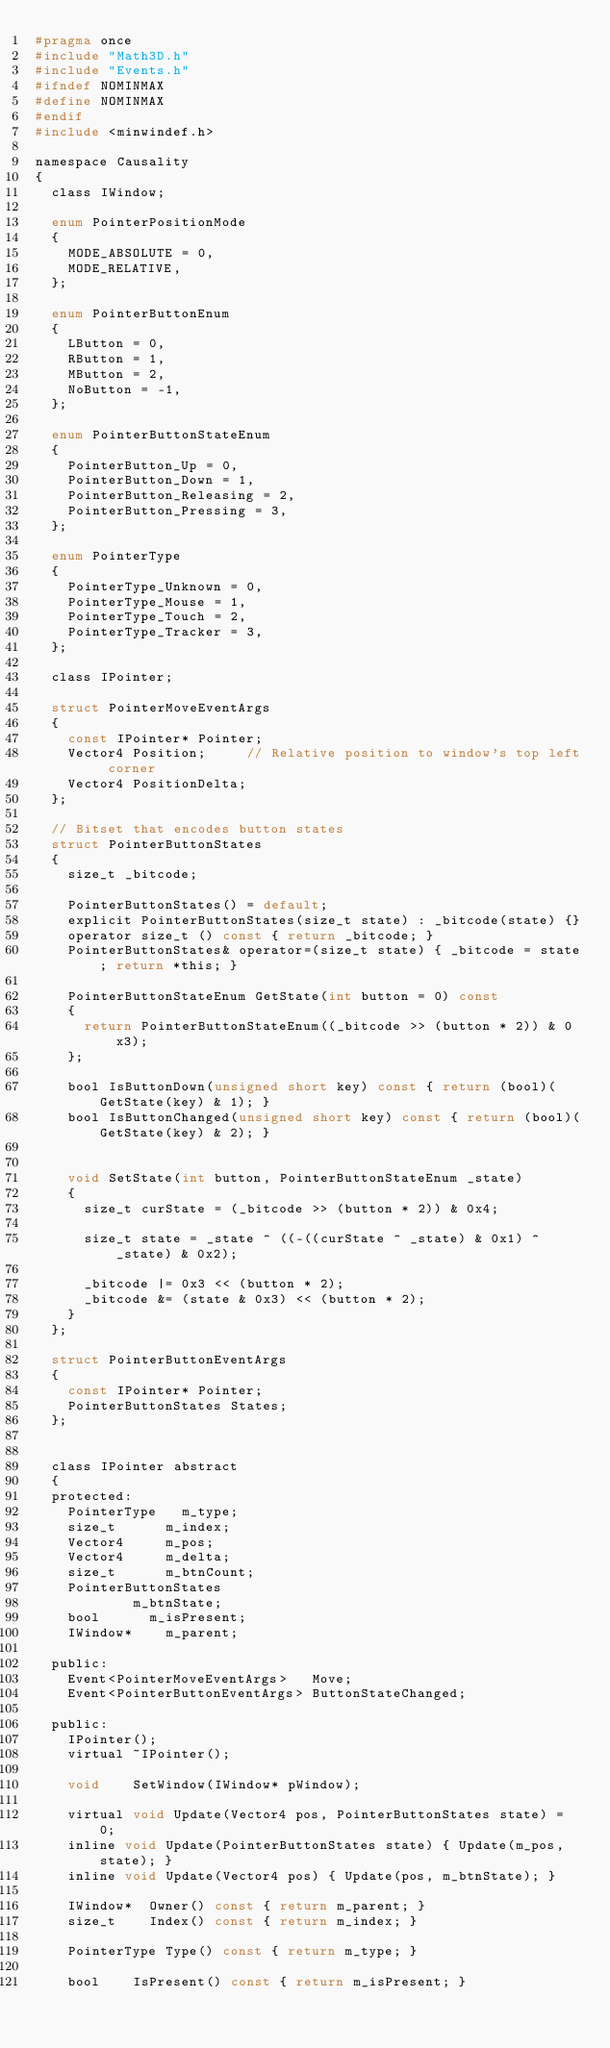Convert code to text. <code><loc_0><loc_0><loc_500><loc_500><_C_>#pragma once
#include "Math3D.h"
#include "Events.h"
#ifndef NOMINMAX 
#define NOMINMAX
#endif
#include <minwindef.h>

namespace Causality
{
	class IWindow;

	enum PointerPositionMode
	{
		MODE_ABSOLUTE = 0,
		MODE_RELATIVE,
	};

	enum PointerButtonEnum
	{
		LButton = 0,
		RButton = 1,
		MButton = 2,
		NoButton = -1,
	};

	enum PointerButtonStateEnum
	{
		PointerButton_Up = 0,
		PointerButton_Down = 1,
		PointerButton_Releasing = 2,
		PointerButton_Pressing = 3,
	};

	enum PointerType
	{
		PointerType_Unknown = 0,
		PointerType_Mouse = 1,
		PointerType_Touch = 2,
		PointerType_Tracker = 3,
	};

	class IPointer;

	struct PointerMoveEventArgs
	{
		const IPointer* Pointer;
		Vector4	Position; 		// Relative position to window's top left corner
		Vector4 PositionDelta;
	};

	// Bitset that encodes button states
	struct PointerButtonStates
	{
		size_t _bitcode;

		PointerButtonStates() = default;
		explicit PointerButtonStates(size_t state) : _bitcode(state) {}
		operator size_t () const { return _bitcode; }
		PointerButtonStates& operator=(size_t state) { _bitcode = state; return *this; }

		PointerButtonStateEnum GetState(int button = 0) const
		{
			return PointerButtonStateEnum((_bitcode >> (button * 2)) & 0x3);
		};

		bool IsButtonDown(unsigned short key) const { return (bool)(GetState(key) & 1); }
		bool IsButtonChanged(unsigned short key) const { return (bool)(GetState(key) & 2); }


		void SetState(int button, PointerButtonStateEnum _state)
		{
			size_t curState = (_bitcode >> (button * 2)) & 0x4;

			size_t state = _state ^ ((-((curState ^ _state) & 0x1) ^ _state) & 0x2);

			_bitcode |= 0x3 << (button * 2);
			_bitcode &= (state & 0x3) << (button * 2);
		}
	};

	struct PointerButtonEventArgs
	{
		const IPointer* Pointer;
		PointerButtonStates	States;
	};


	class IPointer abstract
	{
	protected:
		PointerType		m_type;
		size_t			m_index;
		Vector4			m_pos;
		Vector4			m_delta;
		size_t			m_btnCount;
		PointerButtonStates
						m_btnState;
		bool			m_isPresent;
		IWindow*		m_parent;

	public:
		Event<PointerMoveEventArgs>		Move;
		Event<PointerButtonEventArgs>	ButtonStateChanged;

	public:
		IPointer();
		virtual ~IPointer();

		void		SetWindow(IWindow* pWindow);

		virtual void Update(Vector4 pos, PointerButtonStates state) = 0;
		inline void Update(PointerButtonStates state) { Update(m_pos, state); }
		inline void Update(Vector4 pos) { Update(pos, m_btnState); }

		IWindow*	Owner() const { return m_parent; }
		size_t		Index() const { return m_index; }

		PointerType Type() const { return m_type; }

		bool		IsPresent() const { return m_isPresent; }</code> 